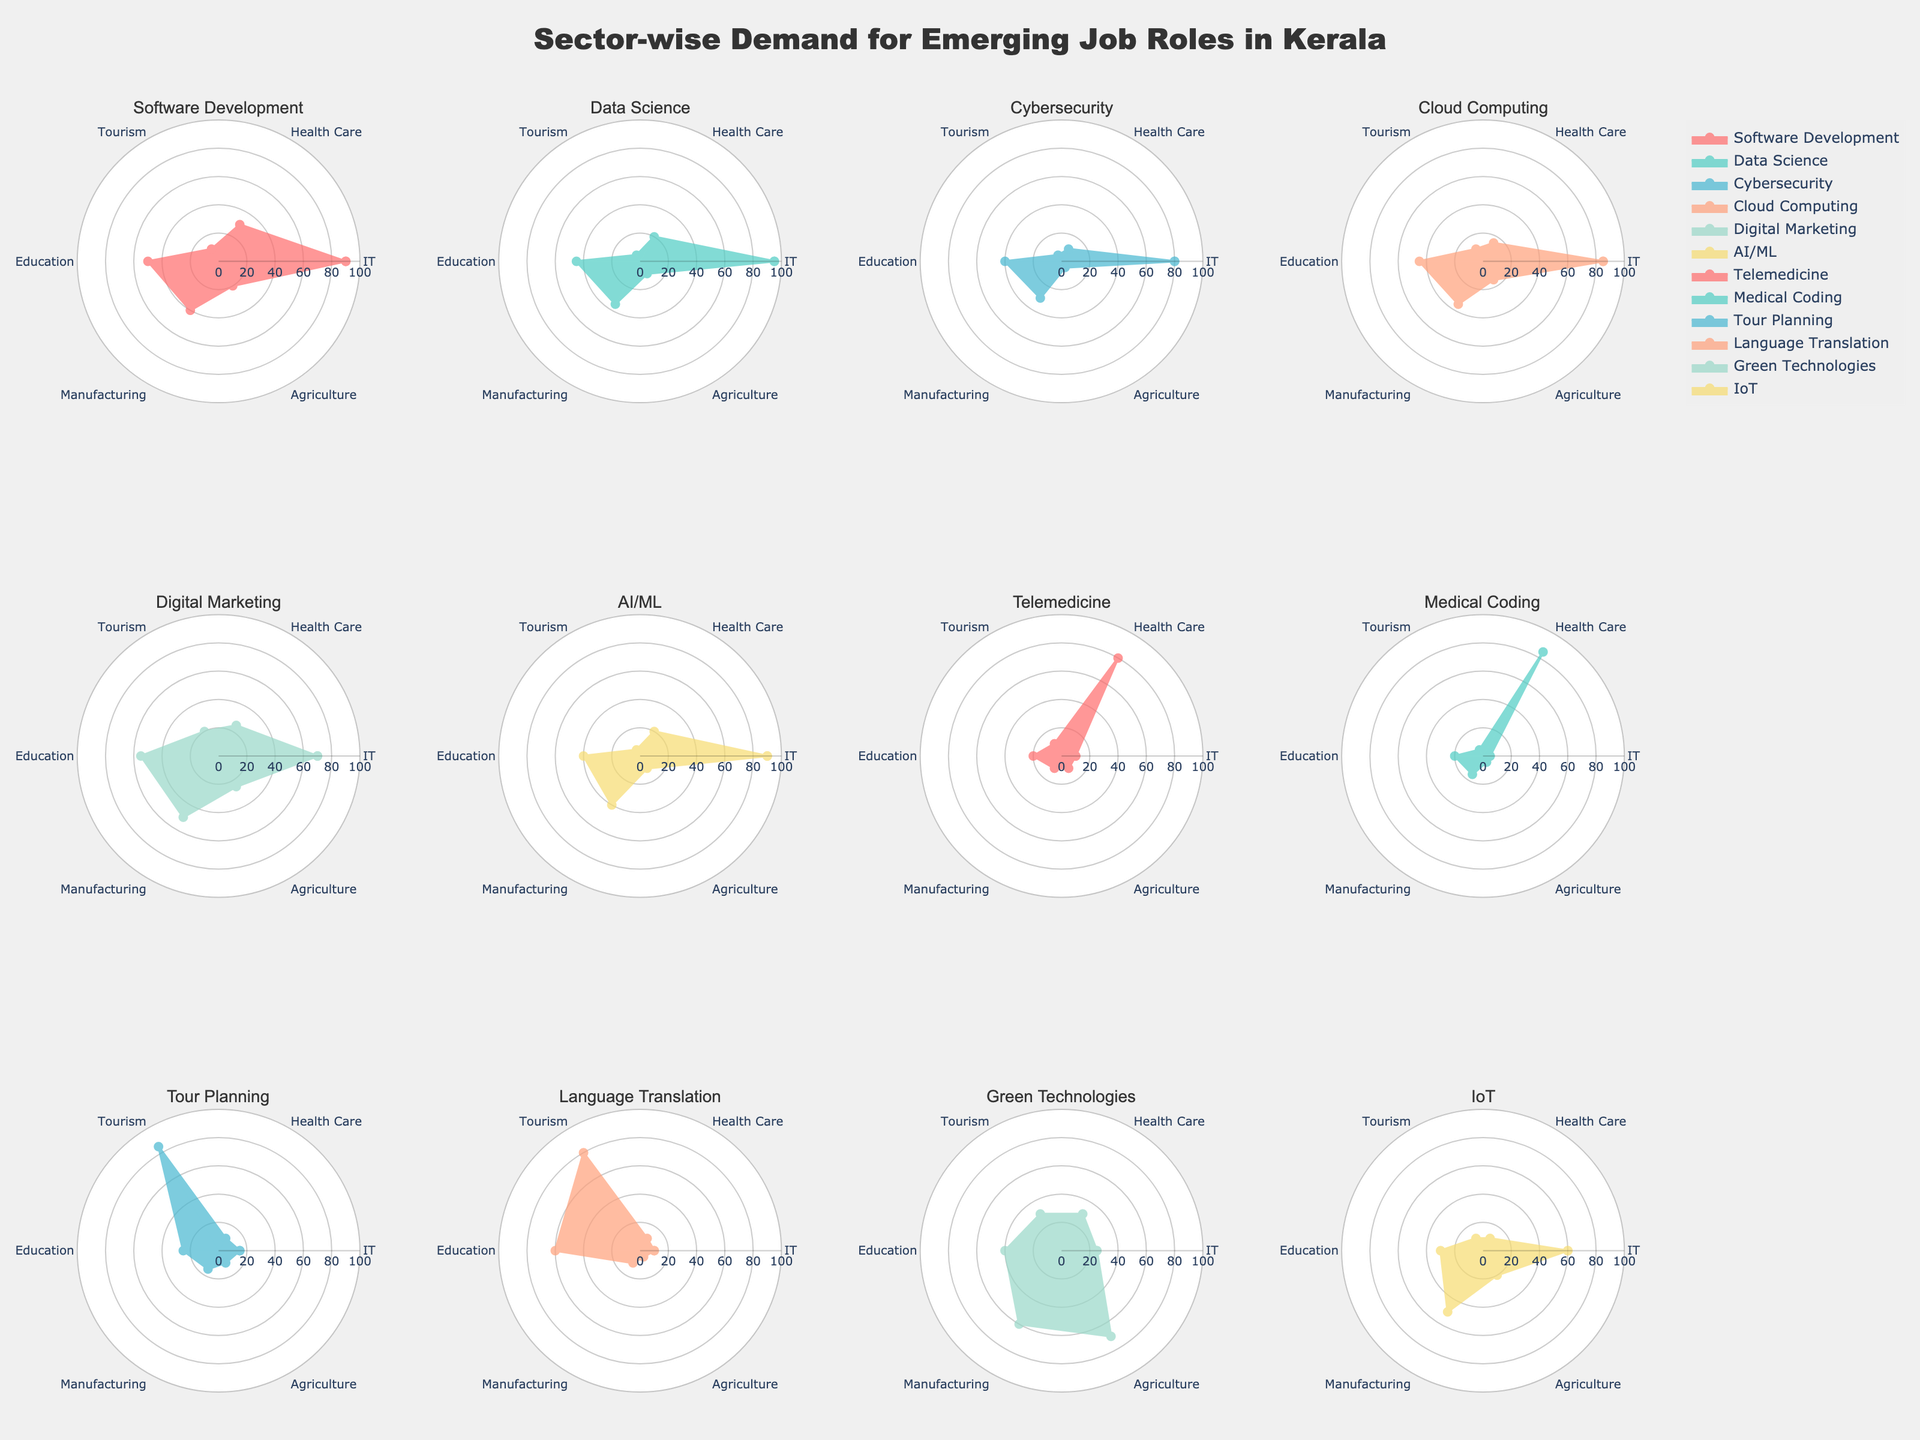What is the title of the chart? The title of the chart is located at the top center of the figure and it provides an overview of what the chart represents.
Answer: Sector-wise Demand for Emerging Job Roles in Kerala What color is used for Software Development sector? By examining the specific radar plot for the Software Development sector, we notice it uses the first color in the custom color palette.
Answer: #FF6B6B or red Which sector has the highest demand in Health Care? In the subplot corresponding to Health Care, look for the highest value, which falls on Medical Coding.
Answer: Medical Coding Compare the demand for Data Science in IT and Manufacturing sectors. By observing the respective values for Data Science in IT (95) and Manufacturing (35), we see a difference.
Answer: The demand in IT is much higher than in Manufacturing Which sector has the lowest demand in Agriculture? From the Agriculture values in all sectors, the minimum value (5) appears in Cybersecurity and Medical Coding sectors.
Answer: Cybersecurity and Medical Coding Which job role has a balanced demand across all listed sectors? A balanced demand means the values should be relatively even across all sectors. Green Technologies shows balanced values: 25, 30, 30, 40, 60, 70.
Answer: Green Technologies What is the sum of demand for Cloud Computing across all sectors? Add the demand values for Cloud Computing: IT (85), Health Care (15), Tourism (10), Education (45), Manufacturing (35), Agriculture (15). Sum is 85 + 15 + 10 + 45 + 35 + 15 = 205.
Answer: 205 Which sector shows the highest variability in demand? Variability can be observed by noting the range of values. Looking at the subplots, Digital Marketing spans from 10 to 70.
Answer: Digital Marketing If you average the demand for AI/ML in IT, Health Care, and Education, what do you get? Add the values: IT (90), Health Care (20), Education (40). Sum is 90 + 20 + 40 = 150. The average is 150/3 = 50.
Answer: 50 How do the demands for IoT in Agriculture compare to Manufacturing? Look at IoT values for Agriculture (20) and Manufacturing (50). They both differ, with Manufacturing having higher demand.
Answer: Manufacturing has higher demand than Agriculture 